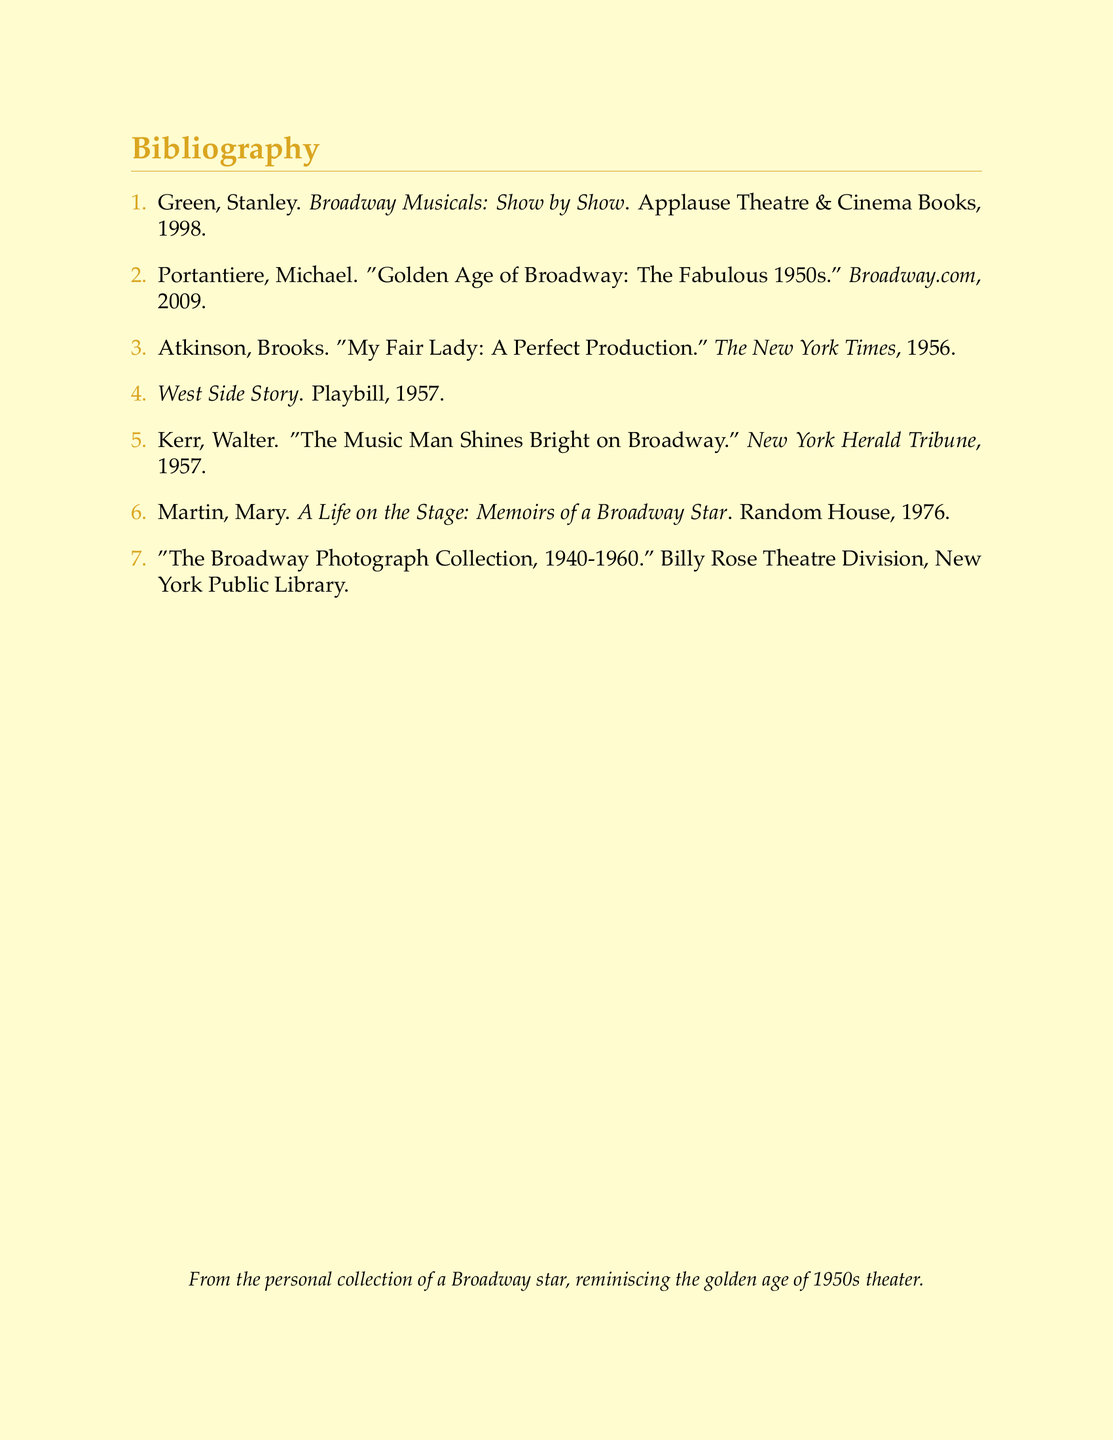What is the title of the first bibliographic entry? The title is taken from the first entry in the bibliography list.
Answer: Broadway Musicals: Show by Show Who wrote "My Fair Lady: A Perfect Production"? The author of the article is specified in the bibliography under the respective entry.
Answer: Brooks Atkinson In what year was "The Music Man Shines Bright on Broadway" published? The publication year can be found next to the title in the bibliography.
Answer: 1957 Which publication features the article "Golden Age of Broadway: The Fabulous 1950s"? The source of the article is indicated in the bibliography entry associated with it.
Answer: Broadway.com How many items are listed in the bibliography? The total number of entries is counted from the enumerated list in the document.
Answer: 7 What is the name of the memoir written by Mary Martin? The title of the memoir is presented in the bibliographic entry.
Answer: A Life on the Stage: Memoirs of a Broadway Star Which theatre division houses "The Broadway Photograph Collection, 1940-1960"? The specific collection mentioned in the bibliography identifies the institution holding it.
Answer: Billy Rose Theatre Division What color is used for the section headings in the document? The color reference for section headings is explicitly mentioned in the document setup.
Answer: Gold 